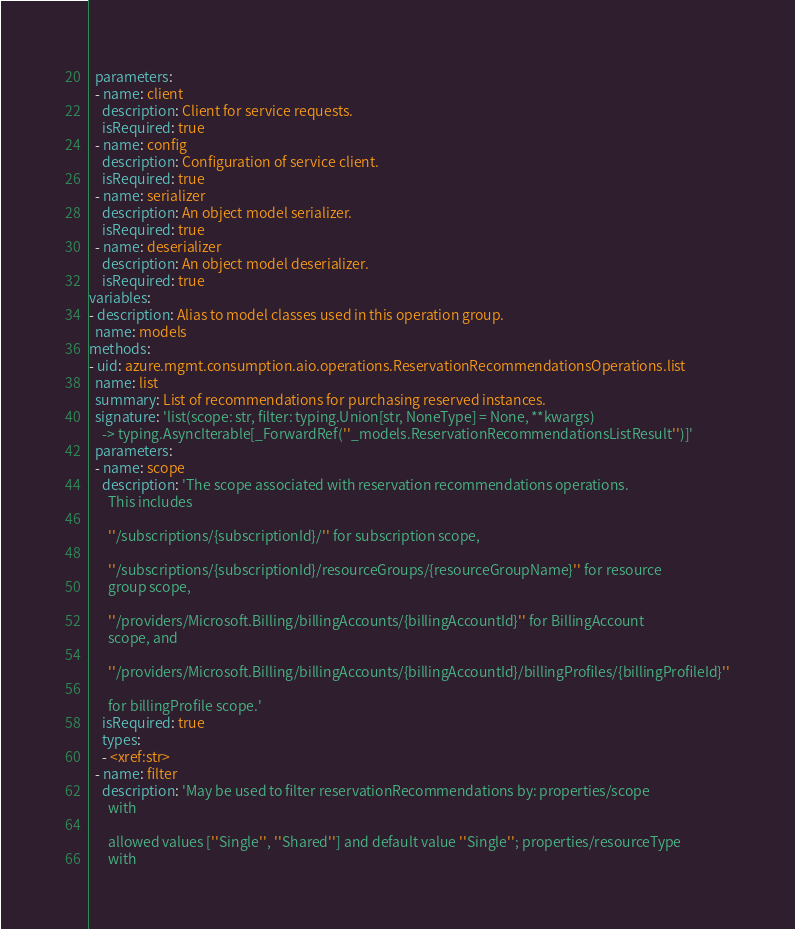Convert code to text. <code><loc_0><loc_0><loc_500><loc_500><_YAML_>  parameters:
  - name: client
    description: Client for service requests.
    isRequired: true
  - name: config
    description: Configuration of service client.
    isRequired: true
  - name: serializer
    description: An object model serializer.
    isRequired: true
  - name: deserializer
    description: An object model deserializer.
    isRequired: true
variables:
- description: Alias to model classes used in this operation group.
  name: models
methods:
- uid: azure.mgmt.consumption.aio.operations.ReservationRecommendationsOperations.list
  name: list
  summary: List of recommendations for purchasing reserved instances.
  signature: 'list(scope: str, filter: typing.Union[str, NoneType] = None, **kwargs)
    -> typing.AsyncIterable[_ForwardRef(''_models.ReservationRecommendationsListResult'')]'
  parameters:
  - name: scope
    description: 'The scope associated with reservation recommendations operations.
      This includes

      ''/subscriptions/{subscriptionId}/'' for subscription scope,

      ''/subscriptions/{subscriptionId}/resourceGroups/{resourceGroupName}'' for resource
      group scope,

      ''/providers/Microsoft.Billing/billingAccounts/{billingAccountId}'' for BillingAccount
      scope, and

      ''/providers/Microsoft.Billing/billingAccounts/{billingAccountId}/billingProfiles/{billingProfileId}''

      for billingProfile scope.'
    isRequired: true
    types:
    - <xref:str>
  - name: filter
    description: 'May be used to filter reservationRecommendations by: properties/scope
      with

      allowed values [''Single'', ''Shared''] and default value ''Single''; properties/resourceType
      with
</code> 